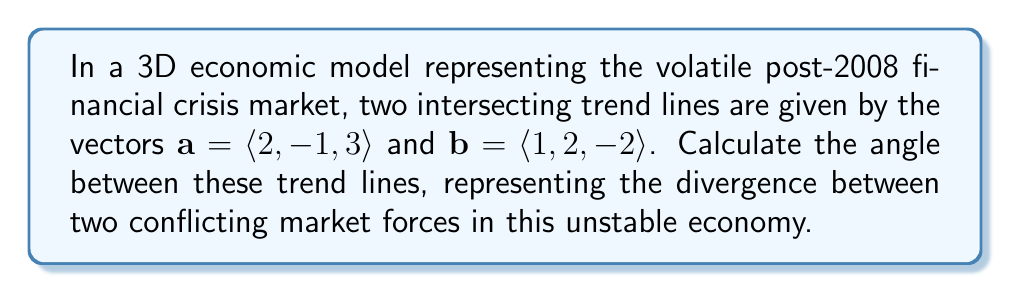What is the answer to this math problem? To find the angle between two vectors in 3D space, we can use the dot product formula:

$$\cos \theta = \frac{\mathbf{a} \cdot \mathbf{b}}{|\mathbf{a}||\mathbf{b}|}$$

Step 1: Calculate the dot product $\mathbf{a} \cdot \mathbf{b}$
$$\mathbf{a} \cdot \mathbf{b} = (2)(1) + (-1)(2) + (3)(-2) = 2 - 2 - 6 = -6$$

Step 2: Calculate the magnitudes of vectors $\mathbf{a}$ and $\mathbf{b}$
$$|\mathbf{a}| = \sqrt{2^2 + (-1)^2 + 3^2} = \sqrt{4 + 1 + 9} = \sqrt{14}$$
$$|\mathbf{b}| = \sqrt{1^2 + 2^2 + (-2)^2} = \sqrt{1 + 4 + 4} = 3$$

Step 3: Substitute into the formula
$$\cos \theta = \frac{-6}{\sqrt{14} \cdot 3} = \frac{-6}{3\sqrt{14}} = -\frac{2}{\sqrt{14}}$$

Step 4: Take the inverse cosine (arccos) of both sides
$$\theta = \arccos\left(-\frac{2}{\sqrt{14}}\right)$$

Step 5: Calculate the result (rounded to two decimal places)
$$\theta \approx 2.16 \text{ radians} \approx 123.84°$$
Answer: $123.84°$ or $2.16$ radians 